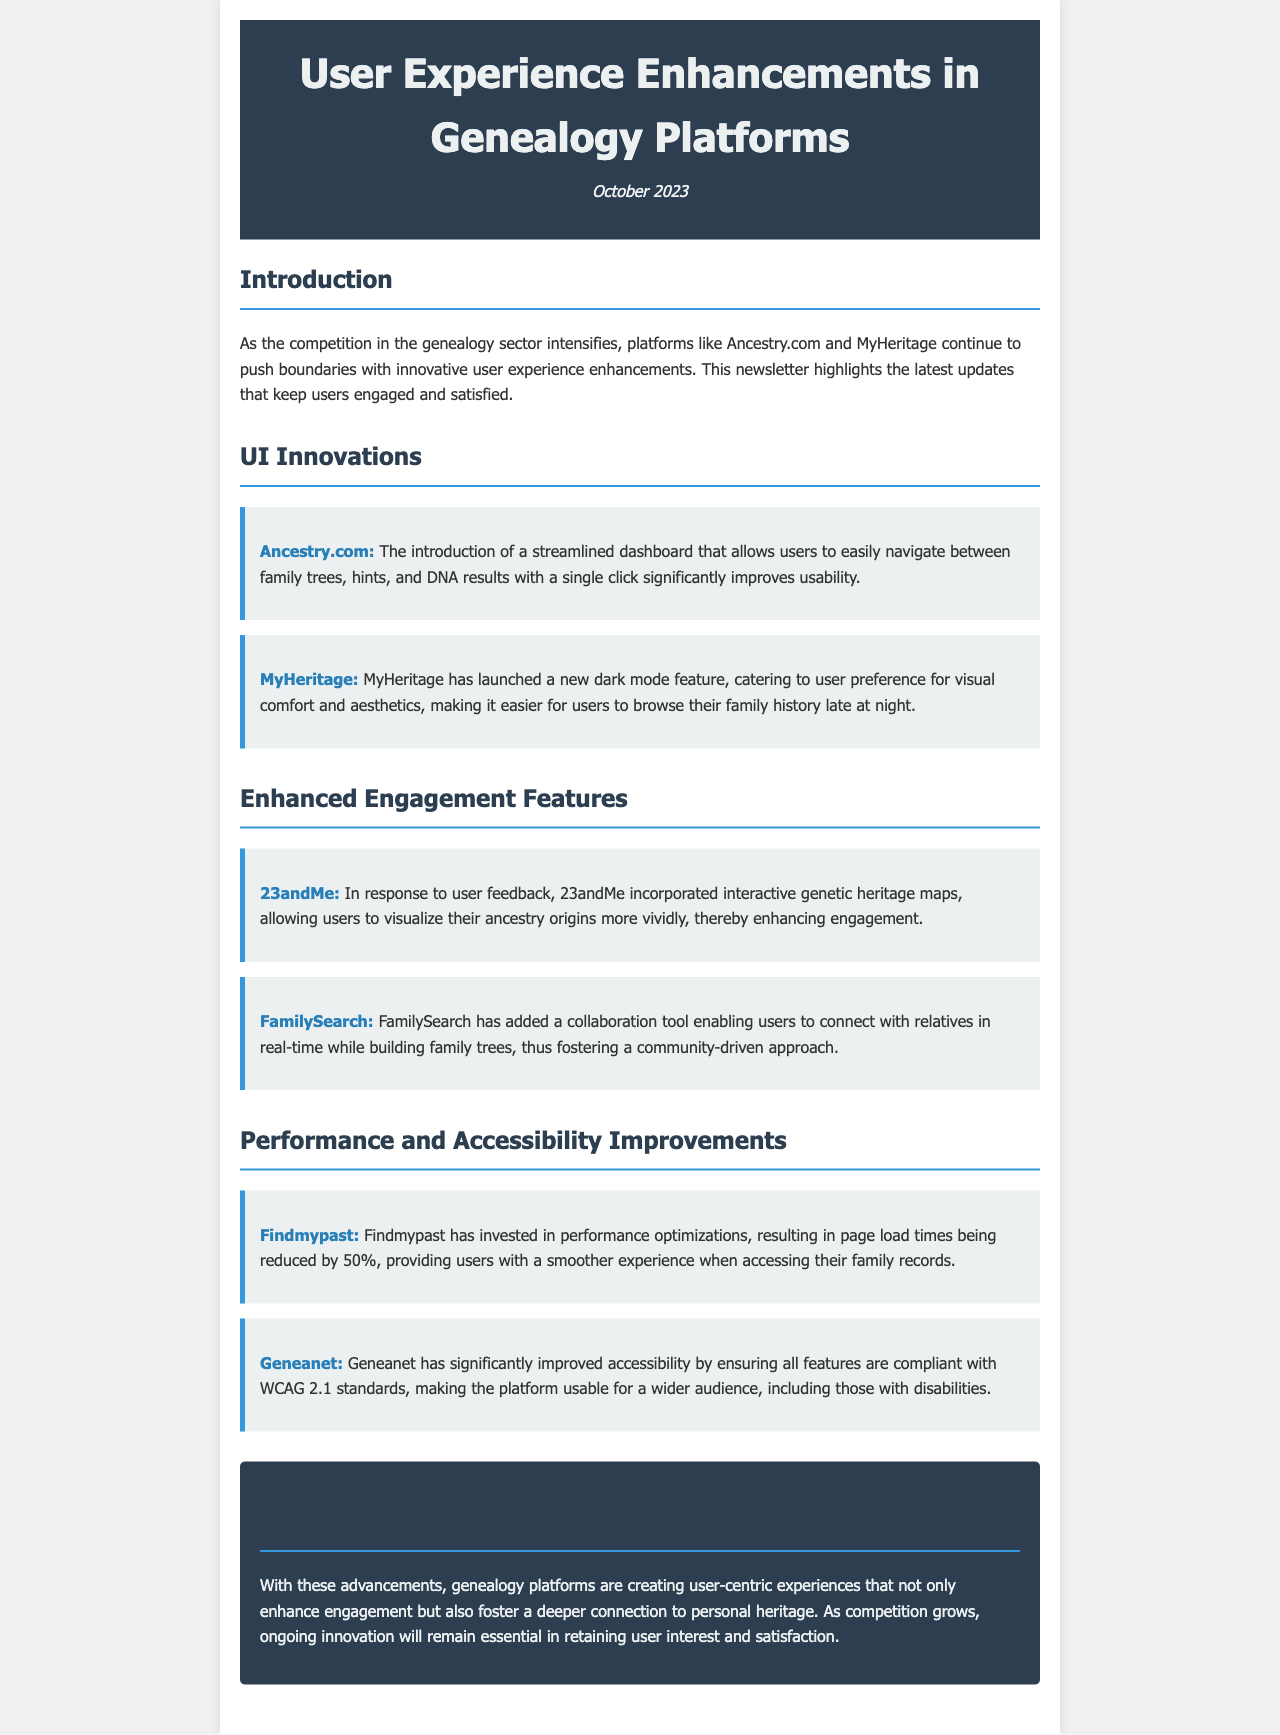What is the title of the newsletter? The title of the newsletter is located in the header section.
Answer: User Experience Enhancements in Genealogy Platforms When was the newsletter published? The publication date is mentioned in the header.
Answer: October 2023 Which platform introduced a streamlined dashboard? The information about the streamlined dashboard is found under the UI Innovations section.
Answer: Ancestry.com What significant feature did MyHeritage launch? This detail is in the UI Innovations section, specifically about MyHeritage.
Answer: Dark mode feature What type of maps did 23andMe incorporate? This is found in the Enhanced Engagement Features section related to 23andMe.
Answer: Interactive genetic heritage maps By what percentage did Findmypast reduce page load times? This detail can be found in the section discussing performance improvements.
Answer: 50% What accessibility standards did Geneanet improve compliance with? This information is provided in the Performance and Accessibility Improvements section.
Answer: WCAG 2.1 What kind of tool did FamilySearch add? The new feature is described in the Enhanced Engagement Features section.
Answer: Collaboration tool What is the main purpose of the newsletter? This can be inferred from the conclusion section summarizing the document's intent.
Answer: Highlight user experience enhancements 